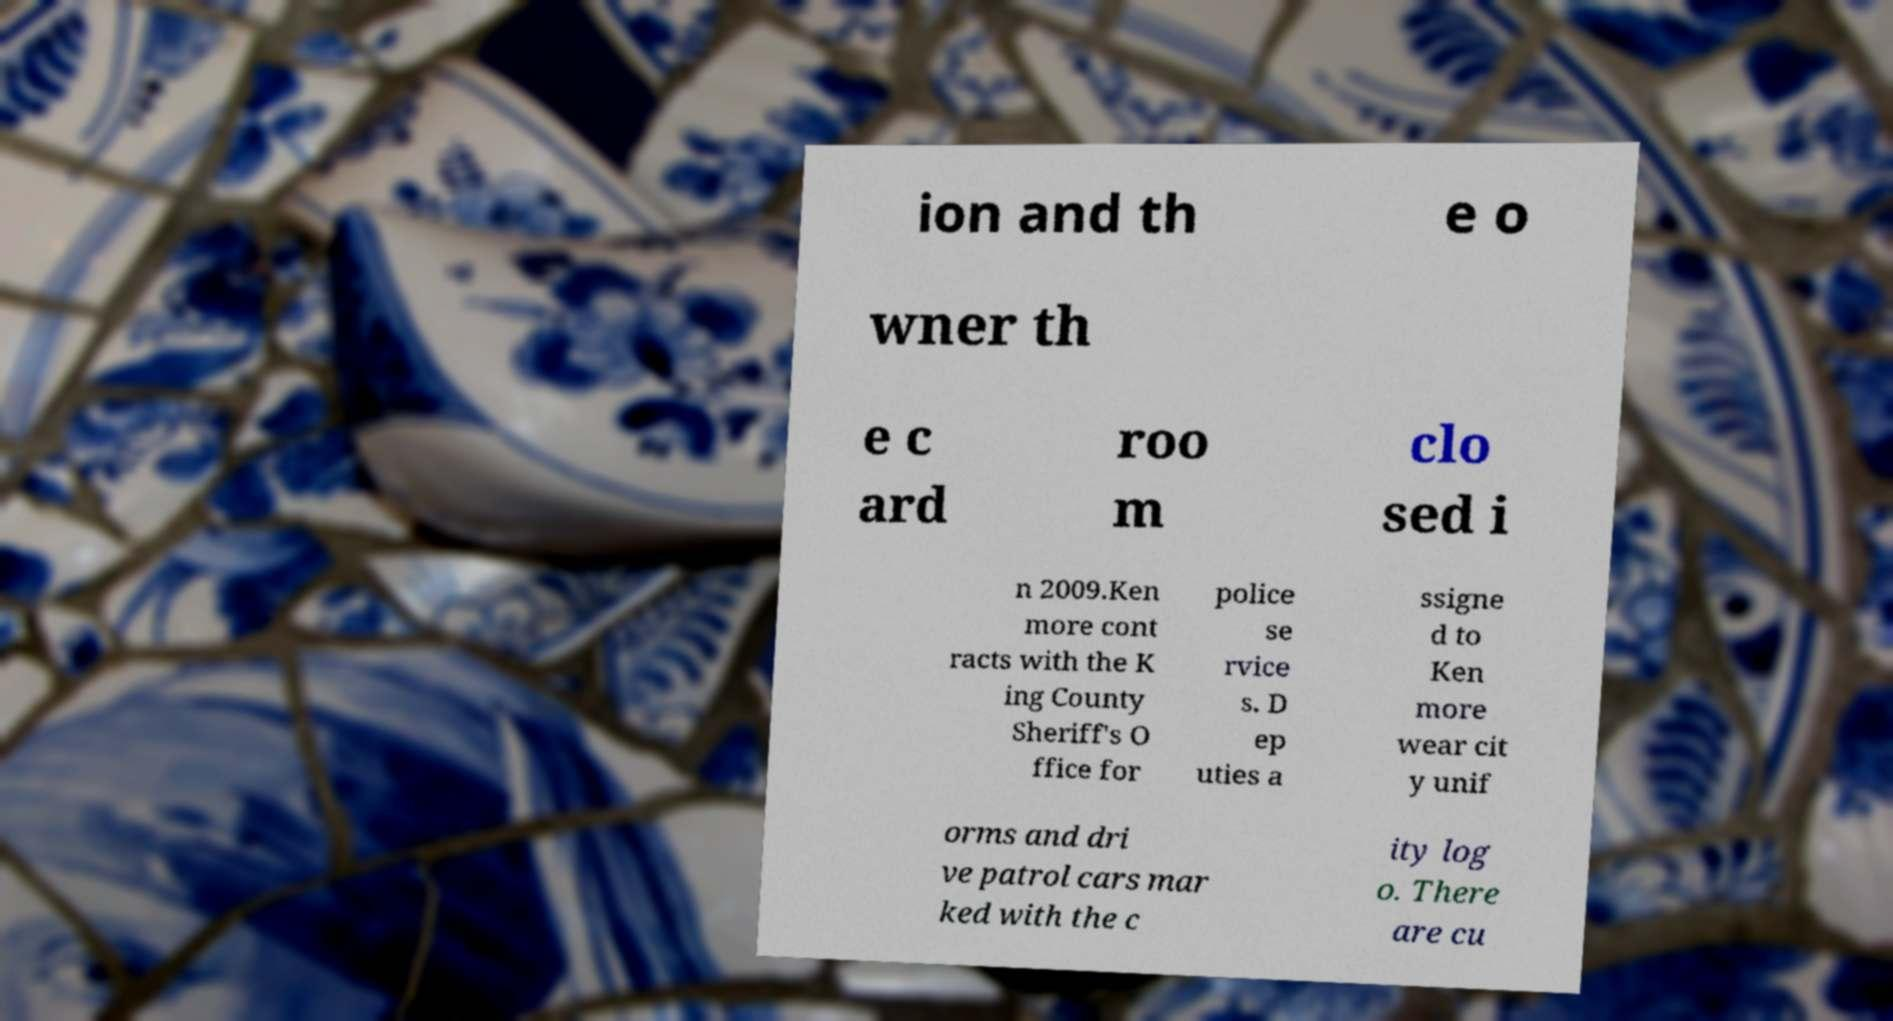There's text embedded in this image that I need extracted. Can you transcribe it verbatim? ion and th e o wner th e c ard roo m clo sed i n 2009.Ken more cont racts with the K ing County Sheriff's O ffice for police se rvice s. D ep uties a ssigne d to Ken more wear cit y unif orms and dri ve patrol cars mar ked with the c ity log o. There are cu 